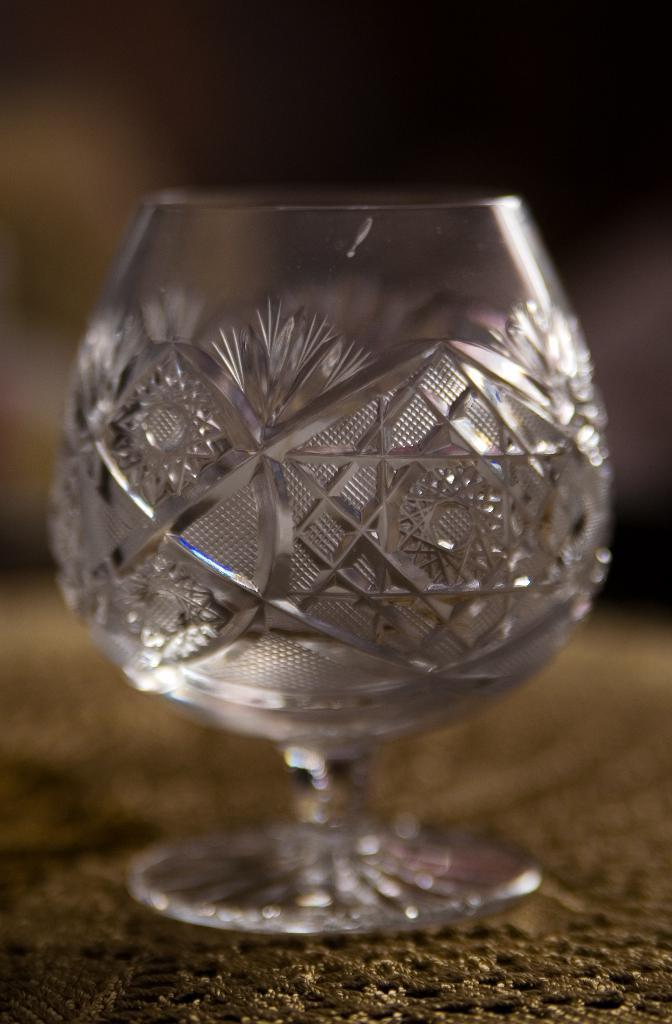What object is visible in the image? There is a glass in the image. Can you describe the background of the image? The background of the image is blurred. How many tails can be seen on the glass in the image? There are no tails present on the glass in the image. What is the fifth object in the image? There are only two objects mentioned in the facts: a glass and a blurred background. Therefore, it is impossible to determine the existence of a fifth object in the image. 